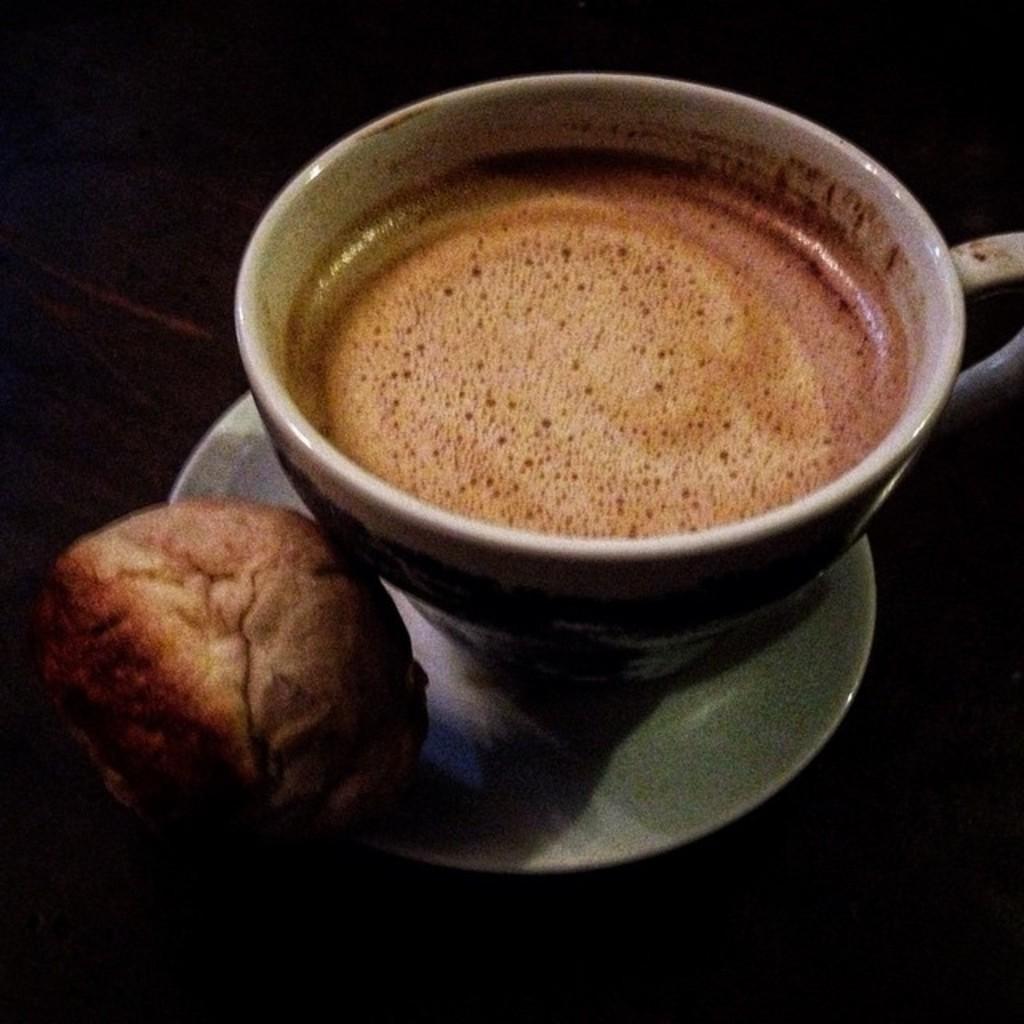Describe this image in one or two sentences. In this image there is one coffee cup kept on one saucer which is in white color, and there is one bun at left side of this image. 